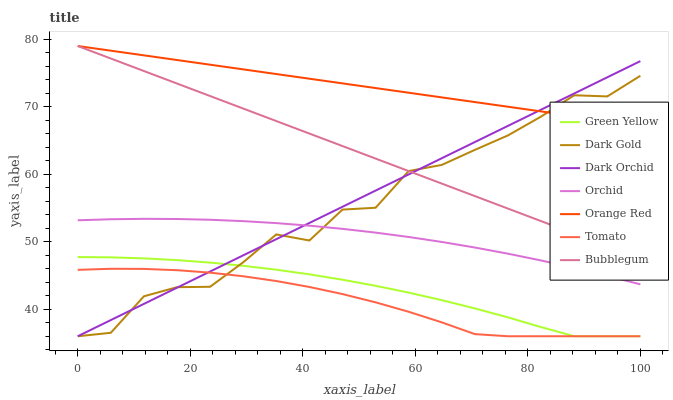Does Dark Gold have the minimum area under the curve?
Answer yes or no. No. Does Dark Gold have the maximum area under the curve?
Answer yes or no. No. Is Dark Orchid the smoothest?
Answer yes or no. No. Is Dark Orchid the roughest?
Answer yes or no. No. Does Bubblegum have the lowest value?
Answer yes or no. No. Does Dark Gold have the highest value?
Answer yes or no. No. Is Green Yellow less than Orchid?
Answer yes or no. Yes. Is Bubblegum greater than Orchid?
Answer yes or no. Yes. Does Green Yellow intersect Orchid?
Answer yes or no. No. 